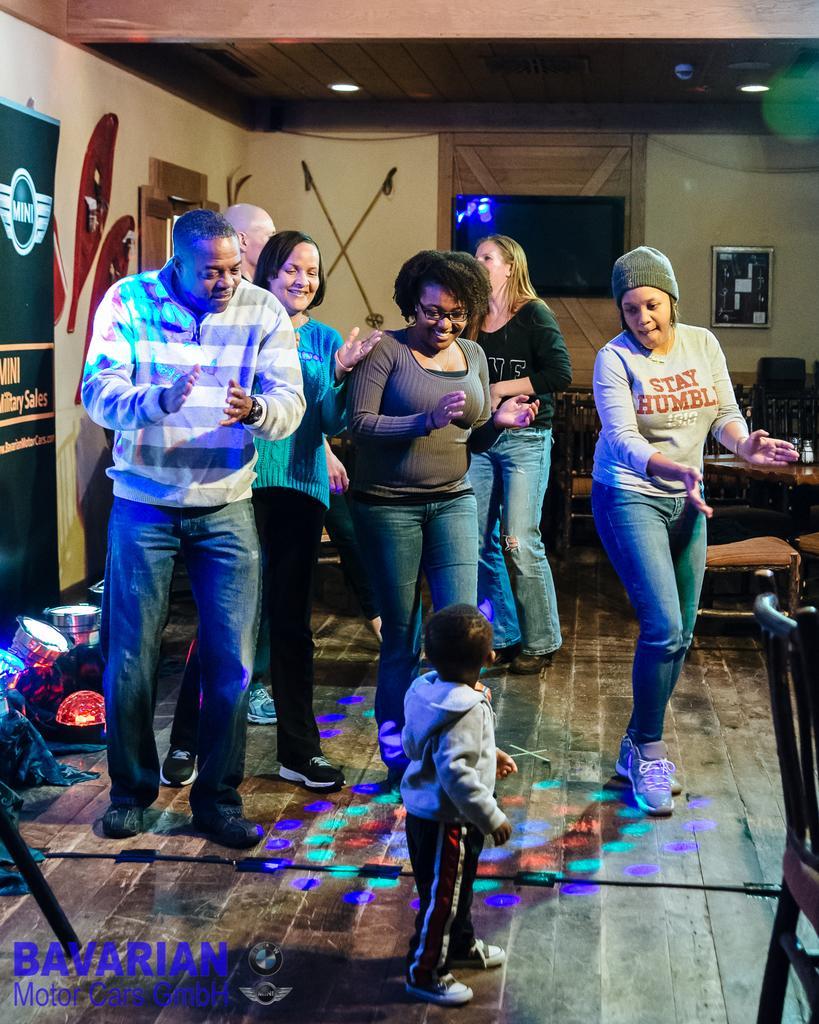Please provide a concise description of this image. In this image there are people and we can see a board. There is a television placed on the wall and we can see a frame. There is a table and we can see chairs. There are lights. 